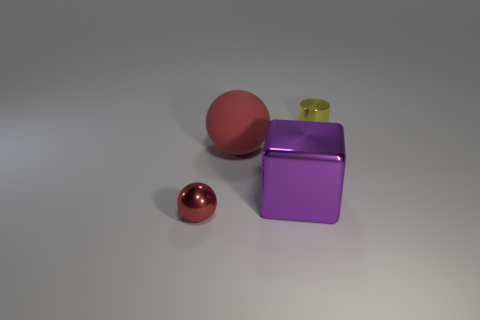Add 1 yellow cylinders. How many objects exist? 5 Subtract all cylinders. How many objects are left? 3 Subtract 0 blue cylinders. How many objects are left? 4 Subtract all red metallic balls. Subtract all tiny yellow cylinders. How many objects are left? 2 Add 4 tiny yellow things. How many tiny yellow things are left? 5 Add 2 big cyan metal cubes. How many big cyan metal cubes exist? 2 